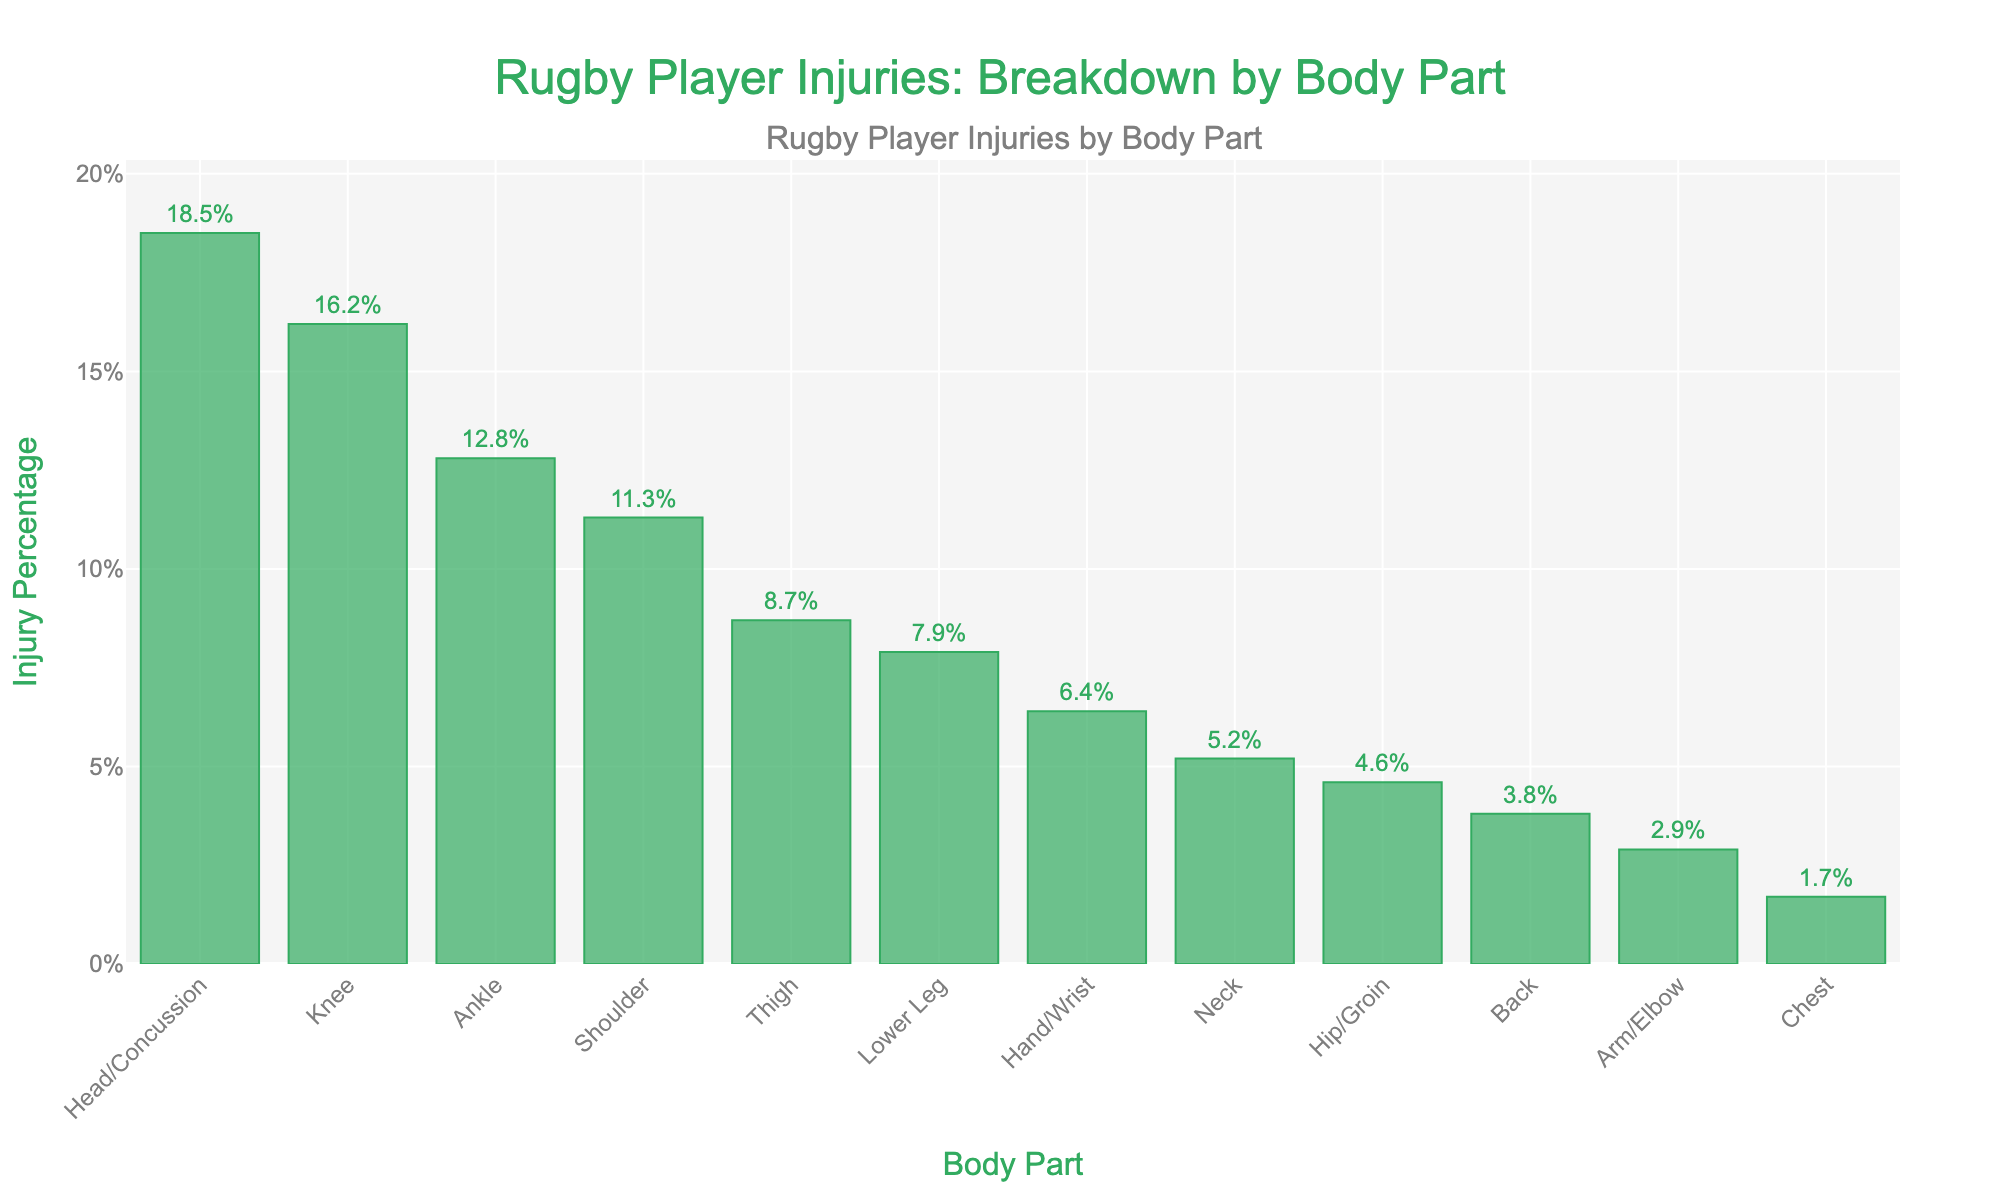What body part has the highest injury percentage? By looking at the bar chart, the tallest bar represents the body part with the highest injury percentage. The "Head/Concussion" has the tallest bar.
Answer: Head/Concussion What is the injury percentage for knee injuries? Find the bar labeled "Knee" and read the percentage value at the top of the bar. The bar for "Knee" shows 16.2%.
Answer: 16.2% Which body part has a higher injury percentage: ankle or shoulder? Compare the heights of the bars labeled "Ankle" and "Shoulder." The "Ankle" bar is taller than the "Shoulder" bar, indicating a higher injury percentage.
Answer: Ankle How much greater is the injury percentage for head/concussion injuries compared to chest injuries? Look at the values for "Head/Concussion" (18.5%) and "Chest" (1.7%). Calculate the difference: 18.5% - 1.7% = 16.8%.
Answer: 16.8% What are the three body parts with the lowest injury percentages? Identify the three shortest bars in the chart, which correspond to the smallest percentages. These are "Chest" (1.7%), "Arm/Elbow" (2.9%), and "Back" (3.8%).
Answer: Chest, Arm/Elbow, Back What is the combined injury percentage for the hip/groin and back injuries? Find the percentage values for "Hip/Groin" (4.6%) and "Back" (3.8%), then add them: 4.6% + 3.8% = 8.4%.
Answer: 8.4% Is the injury percentage for thigh injuries greater than the percentage for lower leg injuries? Compare the percentage values for "Thigh" (8.7%) and "Lower Leg" (7.9%). The "Thigh" percentage is slightly higher than the "Lower Leg."
Answer: Yes How does the percentage for shoulder injuries compare to that for hand/wrist injuries? Look at the bars for "Shoulder" (11.3%) and "Hand/Wrist" (6.4%) and compare their heights. The "Shoulder" bar is taller, indicating a higher percentage.
Answer: Shoulder is higher What is the average injury percentage for the top three body parts with the highest percentages? Identify the top three body parts: "Head/Concussion" (18.5%), "Knee" (16.2%), and "Ankle" (12.8%). Calculate the average: (18.5 + 16.2 + 12.8) / 3 = 15.83%.
Answer: 15.83% Which body part has a similar injury percentage to the back? Find the percentage for "Back" (3.8%) and look for a bar with a value close to it. The "Hip/Groin" has a percentage of 4.6%, which is relatively close.
Answer: Hip/Groin 